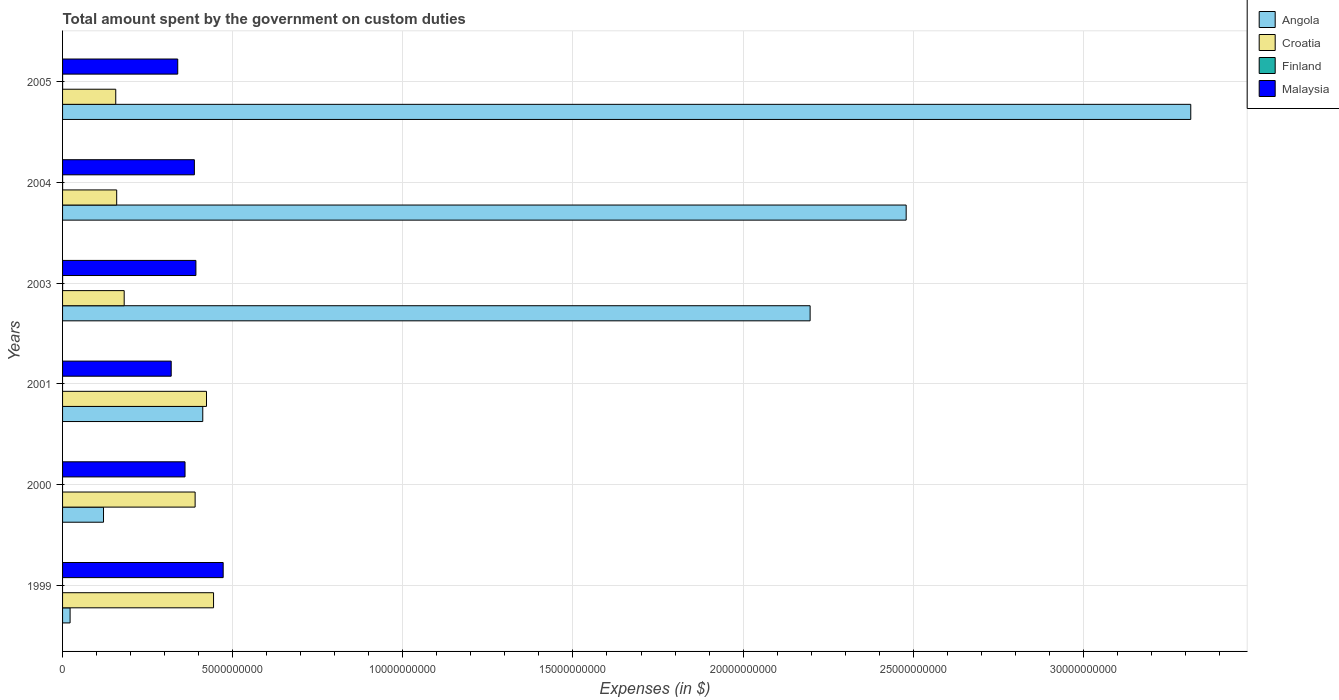Are the number of bars per tick equal to the number of legend labels?
Provide a succinct answer. No. How many bars are there on the 1st tick from the bottom?
Provide a succinct answer. 3. What is the label of the 2nd group of bars from the top?
Your answer should be compact. 2004. In how many cases, is the number of bars for a given year not equal to the number of legend labels?
Provide a succinct answer. 3. Across all years, what is the maximum amount spent on custom duties by the government in Croatia?
Your answer should be compact. 4.44e+09. Across all years, what is the minimum amount spent on custom duties by the government in Angola?
Your answer should be very brief. 2.21e+08. In which year was the amount spent on custom duties by the government in Malaysia maximum?
Provide a short and direct response. 1999. What is the total amount spent on custom duties by the government in Croatia in the graph?
Provide a short and direct response. 1.75e+1. What is the difference between the amount spent on custom duties by the government in Finland in 2003 and that in 2005?
Make the answer very short. 0. What is the difference between the amount spent on custom duties by the government in Malaysia in 2000 and the amount spent on custom duties by the government in Croatia in 2003?
Make the answer very short. 1.79e+09. What is the average amount spent on custom duties by the government in Finland per year?
Offer a very short reply. 5.00e+05. In the year 2003, what is the difference between the amount spent on custom duties by the government in Finland and amount spent on custom duties by the government in Croatia?
Make the answer very short. -1.81e+09. In how many years, is the amount spent on custom duties by the government in Croatia greater than 9000000000 $?
Ensure brevity in your answer.  0. What is the ratio of the amount spent on custom duties by the government in Croatia in 1999 to that in 2003?
Keep it short and to the point. 2.45. Is the amount spent on custom duties by the government in Angola in 2000 less than that in 2005?
Give a very brief answer. Yes. Is the difference between the amount spent on custom duties by the government in Finland in 2003 and 2005 greater than the difference between the amount spent on custom duties by the government in Croatia in 2003 and 2005?
Ensure brevity in your answer.  No. What is the difference between the highest and the second highest amount spent on custom duties by the government in Croatia?
Provide a succinct answer. 2.07e+08. What is the difference between the highest and the lowest amount spent on custom duties by the government in Angola?
Provide a succinct answer. 3.29e+1. How many bars are there?
Your response must be concise. 21. How many years are there in the graph?
Your answer should be very brief. 6. Does the graph contain any zero values?
Provide a short and direct response. Yes. Does the graph contain grids?
Give a very brief answer. Yes. Where does the legend appear in the graph?
Your response must be concise. Top right. What is the title of the graph?
Give a very brief answer. Total amount spent by the government on custom duties. What is the label or title of the X-axis?
Provide a short and direct response. Expenses (in $). What is the label or title of the Y-axis?
Ensure brevity in your answer.  Years. What is the Expenses (in $) of Angola in 1999?
Your answer should be compact. 2.21e+08. What is the Expenses (in $) in Croatia in 1999?
Your answer should be very brief. 4.44e+09. What is the Expenses (in $) of Finland in 1999?
Provide a succinct answer. 0. What is the Expenses (in $) in Malaysia in 1999?
Your answer should be compact. 4.72e+09. What is the Expenses (in $) in Angola in 2000?
Offer a terse response. 1.20e+09. What is the Expenses (in $) in Croatia in 2000?
Your response must be concise. 3.90e+09. What is the Expenses (in $) of Finland in 2000?
Offer a very short reply. 0. What is the Expenses (in $) of Malaysia in 2000?
Give a very brief answer. 3.60e+09. What is the Expenses (in $) of Angola in 2001?
Your answer should be compact. 4.12e+09. What is the Expenses (in $) of Croatia in 2001?
Your response must be concise. 4.23e+09. What is the Expenses (in $) of Malaysia in 2001?
Provide a succinct answer. 3.19e+09. What is the Expenses (in $) in Angola in 2003?
Your answer should be compact. 2.20e+1. What is the Expenses (in $) of Croatia in 2003?
Offer a very short reply. 1.81e+09. What is the Expenses (in $) in Malaysia in 2003?
Provide a succinct answer. 3.92e+09. What is the Expenses (in $) in Angola in 2004?
Your answer should be very brief. 2.48e+1. What is the Expenses (in $) of Croatia in 2004?
Your answer should be compact. 1.59e+09. What is the Expenses (in $) of Finland in 2004?
Offer a very short reply. 1.00e+06. What is the Expenses (in $) of Malaysia in 2004?
Make the answer very short. 3.87e+09. What is the Expenses (in $) of Angola in 2005?
Ensure brevity in your answer.  3.32e+1. What is the Expenses (in $) in Croatia in 2005?
Offer a very short reply. 1.56e+09. What is the Expenses (in $) in Malaysia in 2005?
Provide a short and direct response. 3.38e+09. Across all years, what is the maximum Expenses (in $) of Angola?
Your response must be concise. 3.32e+1. Across all years, what is the maximum Expenses (in $) in Croatia?
Ensure brevity in your answer.  4.44e+09. Across all years, what is the maximum Expenses (in $) of Finland?
Your answer should be compact. 1.00e+06. Across all years, what is the maximum Expenses (in $) in Malaysia?
Your answer should be very brief. 4.72e+09. Across all years, what is the minimum Expenses (in $) in Angola?
Your response must be concise. 2.21e+08. Across all years, what is the minimum Expenses (in $) in Croatia?
Provide a short and direct response. 1.56e+09. Across all years, what is the minimum Expenses (in $) of Finland?
Make the answer very short. 0. Across all years, what is the minimum Expenses (in $) of Malaysia?
Your answer should be compact. 3.19e+09. What is the total Expenses (in $) in Angola in the graph?
Offer a very short reply. 8.55e+1. What is the total Expenses (in $) in Croatia in the graph?
Offer a very short reply. 1.75e+1. What is the total Expenses (in $) of Finland in the graph?
Make the answer very short. 3.00e+06. What is the total Expenses (in $) of Malaysia in the graph?
Your response must be concise. 2.27e+1. What is the difference between the Expenses (in $) in Angola in 1999 and that in 2000?
Give a very brief answer. -9.82e+08. What is the difference between the Expenses (in $) in Croatia in 1999 and that in 2000?
Ensure brevity in your answer.  5.41e+08. What is the difference between the Expenses (in $) in Malaysia in 1999 and that in 2000?
Your answer should be compact. 1.12e+09. What is the difference between the Expenses (in $) in Angola in 1999 and that in 2001?
Offer a very short reply. -3.90e+09. What is the difference between the Expenses (in $) in Croatia in 1999 and that in 2001?
Offer a very short reply. 2.07e+08. What is the difference between the Expenses (in $) of Malaysia in 1999 and that in 2001?
Provide a succinct answer. 1.53e+09. What is the difference between the Expenses (in $) in Angola in 1999 and that in 2003?
Give a very brief answer. -2.17e+1. What is the difference between the Expenses (in $) in Croatia in 1999 and that in 2003?
Offer a terse response. 2.63e+09. What is the difference between the Expenses (in $) in Malaysia in 1999 and that in 2003?
Your answer should be very brief. 8.01e+08. What is the difference between the Expenses (in $) of Angola in 1999 and that in 2004?
Make the answer very short. -2.46e+1. What is the difference between the Expenses (in $) of Croatia in 1999 and that in 2004?
Your answer should be very brief. 2.85e+09. What is the difference between the Expenses (in $) of Malaysia in 1999 and that in 2004?
Your answer should be very brief. 8.46e+08. What is the difference between the Expenses (in $) of Angola in 1999 and that in 2005?
Your answer should be very brief. -3.29e+1. What is the difference between the Expenses (in $) of Croatia in 1999 and that in 2005?
Offer a very short reply. 2.87e+09. What is the difference between the Expenses (in $) in Malaysia in 1999 and that in 2005?
Your answer should be very brief. 1.34e+09. What is the difference between the Expenses (in $) of Angola in 2000 and that in 2001?
Make the answer very short. -2.92e+09. What is the difference between the Expenses (in $) of Croatia in 2000 and that in 2001?
Offer a very short reply. -3.34e+08. What is the difference between the Expenses (in $) in Malaysia in 2000 and that in 2001?
Make the answer very short. 4.06e+08. What is the difference between the Expenses (in $) in Angola in 2000 and that in 2003?
Offer a very short reply. -2.08e+1. What is the difference between the Expenses (in $) of Croatia in 2000 and that in 2003?
Your answer should be compact. 2.09e+09. What is the difference between the Expenses (in $) of Malaysia in 2000 and that in 2003?
Make the answer very short. -3.20e+08. What is the difference between the Expenses (in $) of Angola in 2000 and that in 2004?
Ensure brevity in your answer.  -2.36e+1. What is the difference between the Expenses (in $) of Croatia in 2000 and that in 2004?
Give a very brief answer. 2.31e+09. What is the difference between the Expenses (in $) of Malaysia in 2000 and that in 2004?
Your answer should be very brief. -2.75e+08. What is the difference between the Expenses (in $) in Angola in 2000 and that in 2005?
Make the answer very short. -3.20e+1. What is the difference between the Expenses (in $) in Croatia in 2000 and that in 2005?
Your answer should be compact. 2.33e+09. What is the difference between the Expenses (in $) of Malaysia in 2000 and that in 2005?
Ensure brevity in your answer.  2.14e+08. What is the difference between the Expenses (in $) in Angola in 2001 and that in 2003?
Make the answer very short. -1.79e+1. What is the difference between the Expenses (in $) in Croatia in 2001 and that in 2003?
Provide a succinct answer. 2.42e+09. What is the difference between the Expenses (in $) of Malaysia in 2001 and that in 2003?
Give a very brief answer. -7.26e+08. What is the difference between the Expenses (in $) in Angola in 2001 and that in 2004?
Offer a terse response. -2.07e+1. What is the difference between the Expenses (in $) of Croatia in 2001 and that in 2004?
Give a very brief answer. 2.64e+09. What is the difference between the Expenses (in $) in Malaysia in 2001 and that in 2004?
Offer a terse response. -6.81e+08. What is the difference between the Expenses (in $) in Angola in 2001 and that in 2005?
Ensure brevity in your answer.  -2.90e+1. What is the difference between the Expenses (in $) of Croatia in 2001 and that in 2005?
Keep it short and to the point. 2.67e+09. What is the difference between the Expenses (in $) of Malaysia in 2001 and that in 2005?
Your response must be concise. -1.92e+08. What is the difference between the Expenses (in $) in Angola in 2003 and that in 2004?
Make the answer very short. -2.82e+09. What is the difference between the Expenses (in $) of Croatia in 2003 and that in 2004?
Ensure brevity in your answer.  2.20e+08. What is the difference between the Expenses (in $) of Malaysia in 2003 and that in 2004?
Offer a terse response. 4.50e+07. What is the difference between the Expenses (in $) in Angola in 2003 and that in 2005?
Your answer should be compact. -1.12e+1. What is the difference between the Expenses (in $) of Croatia in 2003 and that in 2005?
Ensure brevity in your answer.  2.48e+08. What is the difference between the Expenses (in $) of Finland in 2003 and that in 2005?
Offer a very short reply. 0. What is the difference between the Expenses (in $) of Malaysia in 2003 and that in 2005?
Offer a very short reply. 5.34e+08. What is the difference between the Expenses (in $) of Angola in 2004 and that in 2005?
Provide a succinct answer. -8.36e+09. What is the difference between the Expenses (in $) of Croatia in 2004 and that in 2005?
Make the answer very short. 2.78e+07. What is the difference between the Expenses (in $) of Finland in 2004 and that in 2005?
Provide a succinct answer. 0. What is the difference between the Expenses (in $) in Malaysia in 2004 and that in 2005?
Provide a succinct answer. 4.89e+08. What is the difference between the Expenses (in $) in Angola in 1999 and the Expenses (in $) in Croatia in 2000?
Keep it short and to the point. -3.67e+09. What is the difference between the Expenses (in $) in Angola in 1999 and the Expenses (in $) in Malaysia in 2000?
Your answer should be very brief. -3.38e+09. What is the difference between the Expenses (in $) in Croatia in 1999 and the Expenses (in $) in Malaysia in 2000?
Provide a short and direct response. 8.38e+08. What is the difference between the Expenses (in $) in Angola in 1999 and the Expenses (in $) in Croatia in 2001?
Offer a very short reply. -4.01e+09. What is the difference between the Expenses (in $) in Angola in 1999 and the Expenses (in $) in Malaysia in 2001?
Give a very brief answer. -2.97e+09. What is the difference between the Expenses (in $) in Croatia in 1999 and the Expenses (in $) in Malaysia in 2001?
Offer a very short reply. 1.24e+09. What is the difference between the Expenses (in $) in Angola in 1999 and the Expenses (in $) in Croatia in 2003?
Offer a very short reply. -1.59e+09. What is the difference between the Expenses (in $) in Angola in 1999 and the Expenses (in $) in Finland in 2003?
Give a very brief answer. 2.20e+08. What is the difference between the Expenses (in $) of Angola in 1999 and the Expenses (in $) of Malaysia in 2003?
Provide a short and direct response. -3.70e+09. What is the difference between the Expenses (in $) in Croatia in 1999 and the Expenses (in $) in Finland in 2003?
Keep it short and to the point. 4.44e+09. What is the difference between the Expenses (in $) of Croatia in 1999 and the Expenses (in $) of Malaysia in 2003?
Offer a very short reply. 5.18e+08. What is the difference between the Expenses (in $) of Angola in 1999 and the Expenses (in $) of Croatia in 2004?
Keep it short and to the point. -1.37e+09. What is the difference between the Expenses (in $) of Angola in 1999 and the Expenses (in $) of Finland in 2004?
Ensure brevity in your answer.  2.20e+08. What is the difference between the Expenses (in $) of Angola in 1999 and the Expenses (in $) of Malaysia in 2004?
Your response must be concise. -3.65e+09. What is the difference between the Expenses (in $) of Croatia in 1999 and the Expenses (in $) of Finland in 2004?
Offer a very short reply. 4.44e+09. What is the difference between the Expenses (in $) of Croatia in 1999 and the Expenses (in $) of Malaysia in 2004?
Keep it short and to the point. 5.63e+08. What is the difference between the Expenses (in $) of Angola in 1999 and the Expenses (in $) of Croatia in 2005?
Provide a short and direct response. -1.34e+09. What is the difference between the Expenses (in $) in Angola in 1999 and the Expenses (in $) in Finland in 2005?
Your response must be concise. 2.20e+08. What is the difference between the Expenses (in $) of Angola in 1999 and the Expenses (in $) of Malaysia in 2005?
Ensure brevity in your answer.  -3.16e+09. What is the difference between the Expenses (in $) of Croatia in 1999 and the Expenses (in $) of Finland in 2005?
Your answer should be compact. 4.44e+09. What is the difference between the Expenses (in $) of Croatia in 1999 and the Expenses (in $) of Malaysia in 2005?
Offer a very short reply. 1.05e+09. What is the difference between the Expenses (in $) in Angola in 2000 and the Expenses (in $) in Croatia in 2001?
Provide a short and direct response. -3.03e+09. What is the difference between the Expenses (in $) of Angola in 2000 and the Expenses (in $) of Malaysia in 2001?
Provide a short and direct response. -1.99e+09. What is the difference between the Expenses (in $) of Croatia in 2000 and the Expenses (in $) of Malaysia in 2001?
Your response must be concise. 7.03e+08. What is the difference between the Expenses (in $) of Angola in 2000 and the Expenses (in $) of Croatia in 2003?
Your answer should be very brief. -6.08e+08. What is the difference between the Expenses (in $) of Angola in 2000 and the Expenses (in $) of Finland in 2003?
Provide a succinct answer. 1.20e+09. What is the difference between the Expenses (in $) of Angola in 2000 and the Expenses (in $) of Malaysia in 2003?
Make the answer very short. -2.72e+09. What is the difference between the Expenses (in $) of Croatia in 2000 and the Expenses (in $) of Finland in 2003?
Your answer should be compact. 3.90e+09. What is the difference between the Expenses (in $) in Croatia in 2000 and the Expenses (in $) in Malaysia in 2003?
Provide a succinct answer. -2.30e+07. What is the difference between the Expenses (in $) of Angola in 2000 and the Expenses (in $) of Croatia in 2004?
Your answer should be very brief. -3.87e+08. What is the difference between the Expenses (in $) of Angola in 2000 and the Expenses (in $) of Finland in 2004?
Ensure brevity in your answer.  1.20e+09. What is the difference between the Expenses (in $) of Angola in 2000 and the Expenses (in $) of Malaysia in 2004?
Give a very brief answer. -2.67e+09. What is the difference between the Expenses (in $) in Croatia in 2000 and the Expenses (in $) in Finland in 2004?
Keep it short and to the point. 3.90e+09. What is the difference between the Expenses (in $) in Croatia in 2000 and the Expenses (in $) in Malaysia in 2004?
Your response must be concise. 2.20e+07. What is the difference between the Expenses (in $) in Angola in 2000 and the Expenses (in $) in Croatia in 2005?
Ensure brevity in your answer.  -3.60e+08. What is the difference between the Expenses (in $) in Angola in 2000 and the Expenses (in $) in Finland in 2005?
Provide a short and direct response. 1.20e+09. What is the difference between the Expenses (in $) of Angola in 2000 and the Expenses (in $) of Malaysia in 2005?
Provide a succinct answer. -2.18e+09. What is the difference between the Expenses (in $) of Croatia in 2000 and the Expenses (in $) of Finland in 2005?
Give a very brief answer. 3.90e+09. What is the difference between the Expenses (in $) of Croatia in 2000 and the Expenses (in $) of Malaysia in 2005?
Keep it short and to the point. 5.11e+08. What is the difference between the Expenses (in $) of Angola in 2001 and the Expenses (in $) of Croatia in 2003?
Provide a short and direct response. 2.31e+09. What is the difference between the Expenses (in $) of Angola in 2001 and the Expenses (in $) of Finland in 2003?
Give a very brief answer. 4.12e+09. What is the difference between the Expenses (in $) in Angola in 2001 and the Expenses (in $) in Malaysia in 2003?
Provide a short and direct response. 2.01e+08. What is the difference between the Expenses (in $) in Croatia in 2001 and the Expenses (in $) in Finland in 2003?
Ensure brevity in your answer.  4.23e+09. What is the difference between the Expenses (in $) in Croatia in 2001 and the Expenses (in $) in Malaysia in 2003?
Your response must be concise. 3.11e+08. What is the difference between the Expenses (in $) in Angola in 2001 and the Expenses (in $) in Croatia in 2004?
Offer a very short reply. 2.53e+09. What is the difference between the Expenses (in $) in Angola in 2001 and the Expenses (in $) in Finland in 2004?
Your response must be concise. 4.12e+09. What is the difference between the Expenses (in $) in Angola in 2001 and the Expenses (in $) in Malaysia in 2004?
Your response must be concise. 2.46e+08. What is the difference between the Expenses (in $) of Croatia in 2001 and the Expenses (in $) of Finland in 2004?
Your response must be concise. 4.23e+09. What is the difference between the Expenses (in $) of Croatia in 2001 and the Expenses (in $) of Malaysia in 2004?
Make the answer very short. 3.56e+08. What is the difference between the Expenses (in $) in Angola in 2001 and the Expenses (in $) in Croatia in 2005?
Your answer should be compact. 2.56e+09. What is the difference between the Expenses (in $) in Angola in 2001 and the Expenses (in $) in Finland in 2005?
Ensure brevity in your answer.  4.12e+09. What is the difference between the Expenses (in $) of Angola in 2001 and the Expenses (in $) of Malaysia in 2005?
Your answer should be very brief. 7.35e+08. What is the difference between the Expenses (in $) of Croatia in 2001 and the Expenses (in $) of Finland in 2005?
Offer a terse response. 4.23e+09. What is the difference between the Expenses (in $) in Croatia in 2001 and the Expenses (in $) in Malaysia in 2005?
Provide a short and direct response. 8.45e+08. What is the difference between the Expenses (in $) of Angola in 2003 and the Expenses (in $) of Croatia in 2004?
Ensure brevity in your answer.  2.04e+1. What is the difference between the Expenses (in $) of Angola in 2003 and the Expenses (in $) of Finland in 2004?
Your answer should be very brief. 2.20e+1. What is the difference between the Expenses (in $) in Angola in 2003 and the Expenses (in $) in Malaysia in 2004?
Make the answer very short. 1.81e+1. What is the difference between the Expenses (in $) of Croatia in 2003 and the Expenses (in $) of Finland in 2004?
Give a very brief answer. 1.81e+09. What is the difference between the Expenses (in $) of Croatia in 2003 and the Expenses (in $) of Malaysia in 2004?
Keep it short and to the point. -2.06e+09. What is the difference between the Expenses (in $) of Finland in 2003 and the Expenses (in $) of Malaysia in 2004?
Ensure brevity in your answer.  -3.87e+09. What is the difference between the Expenses (in $) in Angola in 2003 and the Expenses (in $) in Croatia in 2005?
Keep it short and to the point. 2.04e+1. What is the difference between the Expenses (in $) of Angola in 2003 and the Expenses (in $) of Finland in 2005?
Provide a succinct answer. 2.20e+1. What is the difference between the Expenses (in $) of Angola in 2003 and the Expenses (in $) of Malaysia in 2005?
Ensure brevity in your answer.  1.86e+1. What is the difference between the Expenses (in $) of Croatia in 2003 and the Expenses (in $) of Finland in 2005?
Keep it short and to the point. 1.81e+09. What is the difference between the Expenses (in $) in Croatia in 2003 and the Expenses (in $) in Malaysia in 2005?
Give a very brief answer. -1.57e+09. What is the difference between the Expenses (in $) of Finland in 2003 and the Expenses (in $) of Malaysia in 2005?
Keep it short and to the point. -3.38e+09. What is the difference between the Expenses (in $) of Angola in 2004 and the Expenses (in $) of Croatia in 2005?
Offer a terse response. 2.32e+1. What is the difference between the Expenses (in $) of Angola in 2004 and the Expenses (in $) of Finland in 2005?
Give a very brief answer. 2.48e+1. What is the difference between the Expenses (in $) in Angola in 2004 and the Expenses (in $) in Malaysia in 2005?
Provide a short and direct response. 2.14e+1. What is the difference between the Expenses (in $) of Croatia in 2004 and the Expenses (in $) of Finland in 2005?
Offer a terse response. 1.59e+09. What is the difference between the Expenses (in $) of Croatia in 2004 and the Expenses (in $) of Malaysia in 2005?
Ensure brevity in your answer.  -1.79e+09. What is the difference between the Expenses (in $) of Finland in 2004 and the Expenses (in $) of Malaysia in 2005?
Give a very brief answer. -3.38e+09. What is the average Expenses (in $) in Angola per year?
Give a very brief answer. 1.42e+1. What is the average Expenses (in $) of Croatia per year?
Provide a short and direct response. 2.92e+09. What is the average Expenses (in $) of Finland per year?
Your answer should be compact. 5.00e+05. What is the average Expenses (in $) in Malaysia per year?
Provide a short and direct response. 3.78e+09. In the year 1999, what is the difference between the Expenses (in $) in Angola and Expenses (in $) in Croatia?
Provide a succinct answer. -4.22e+09. In the year 1999, what is the difference between the Expenses (in $) of Angola and Expenses (in $) of Malaysia?
Offer a very short reply. -4.50e+09. In the year 1999, what is the difference between the Expenses (in $) of Croatia and Expenses (in $) of Malaysia?
Offer a very short reply. -2.83e+08. In the year 2000, what is the difference between the Expenses (in $) in Angola and Expenses (in $) in Croatia?
Your answer should be very brief. -2.69e+09. In the year 2000, what is the difference between the Expenses (in $) in Angola and Expenses (in $) in Malaysia?
Provide a succinct answer. -2.40e+09. In the year 2000, what is the difference between the Expenses (in $) of Croatia and Expenses (in $) of Malaysia?
Provide a succinct answer. 2.97e+08. In the year 2001, what is the difference between the Expenses (in $) of Angola and Expenses (in $) of Croatia?
Offer a very short reply. -1.10e+08. In the year 2001, what is the difference between the Expenses (in $) in Angola and Expenses (in $) in Malaysia?
Your answer should be very brief. 9.27e+08. In the year 2001, what is the difference between the Expenses (in $) of Croatia and Expenses (in $) of Malaysia?
Provide a succinct answer. 1.04e+09. In the year 2003, what is the difference between the Expenses (in $) of Angola and Expenses (in $) of Croatia?
Offer a very short reply. 2.02e+1. In the year 2003, what is the difference between the Expenses (in $) in Angola and Expenses (in $) in Finland?
Offer a very short reply. 2.20e+1. In the year 2003, what is the difference between the Expenses (in $) of Angola and Expenses (in $) of Malaysia?
Your answer should be very brief. 1.81e+1. In the year 2003, what is the difference between the Expenses (in $) in Croatia and Expenses (in $) in Finland?
Your answer should be very brief. 1.81e+09. In the year 2003, what is the difference between the Expenses (in $) in Croatia and Expenses (in $) in Malaysia?
Provide a short and direct response. -2.11e+09. In the year 2003, what is the difference between the Expenses (in $) in Finland and Expenses (in $) in Malaysia?
Give a very brief answer. -3.92e+09. In the year 2004, what is the difference between the Expenses (in $) of Angola and Expenses (in $) of Croatia?
Provide a short and direct response. 2.32e+1. In the year 2004, what is the difference between the Expenses (in $) in Angola and Expenses (in $) in Finland?
Offer a terse response. 2.48e+1. In the year 2004, what is the difference between the Expenses (in $) of Angola and Expenses (in $) of Malaysia?
Keep it short and to the point. 2.09e+1. In the year 2004, what is the difference between the Expenses (in $) in Croatia and Expenses (in $) in Finland?
Ensure brevity in your answer.  1.59e+09. In the year 2004, what is the difference between the Expenses (in $) of Croatia and Expenses (in $) of Malaysia?
Your response must be concise. -2.28e+09. In the year 2004, what is the difference between the Expenses (in $) in Finland and Expenses (in $) in Malaysia?
Offer a terse response. -3.87e+09. In the year 2005, what is the difference between the Expenses (in $) of Angola and Expenses (in $) of Croatia?
Your answer should be very brief. 3.16e+1. In the year 2005, what is the difference between the Expenses (in $) in Angola and Expenses (in $) in Finland?
Your answer should be compact. 3.32e+1. In the year 2005, what is the difference between the Expenses (in $) of Angola and Expenses (in $) of Malaysia?
Provide a short and direct response. 2.98e+1. In the year 2005, what is the difference between the Expenses (in $) of Croatia and Expenses (in $) of Finland?
Offer a terse response. 1.56e+09. In the year 2005, what is the difference between the Expenses (in $) in Croatia and Expenses (in $) in Malaysia?
Make the answer very short. -1.82e+09. In the year 2005, what is the difference between the Expenses (in $) of Finland and Expenses (in $) of Malaysia?
Ensure brevity in your answer.  -3.38e+09. What is the ratio of the Expenses (in $) in Angola in 1999 to that in 2000?
Your response must be concise. 0.18. What is the ratio of the Expenses (in $) of Croatia in 1999 to that in 2000?
Ensure brevity in your answer.  1.14. What is the ratio of the Expenses (in $) in Malaysia in 1999 to that in 2000?
Your answer should be compact. 1.31. What is the ratio of the Expenses (in $) in Angola in 1999 to that in 2001?
Provide a short and direct response. 0.05. What is the ratio of the Expenses (in $) of Croatia in 1999 to that in 2001?
Your answer should be compact. 1.05. What is the ratio of the Expenses (in $) of Malaysia in 1999 to that in 2001?
Offer a very short reply. 1.48. What is the ratio of the Expenses (in $) of Angola in 1999 to that in 2003?
Your answer should be very brief. 0.01. What is the ratio of the Expenses (in $) of Croatia in 1999 to that in 2003?
Offer a very short reply. 2.45. What is the ratio of the Expenses (in $) in Malaysia in 1999 to that in 2003?
Offer a terse response. 1.2. What is the ratio of the Expenses (in $) in Angola in 1999 to that in 2004?
Provide a short and direct response. 0.01. What is the ratio of the Expenses (in $) of Croatia in 1999 to that in 2004?
Your answer should be very brief. 2.79. What is the ratio of the Expenses (in $) of Malaysia in 1999 to that in 2004?
Provide a short and direct response. 1.22. What is the ratio of the Expenses (in $) in Angola in 1999 to that in 2005?
Your response must be concise. 0.01. What is the ratio of the Expenses (in $) in Croatia in 1999 to that in 2005?
Make the answer very short. 2.84. What is the ratio of the Expenses (in $) of Malaysia in 1999 to that in 2005?
Make the answer very short. 1.39. What is the ratio of the Expenses (in $) of Angola in 2000 to that in 2001?
Make the answer very short. 0.29. What is the ratio of the Expenses (in $) in Croatia in 2000 to that in 2001?
Give a very brief answer. 0.92. What is the ratio of the Expenses (in $) in Malaysia in 2000 to that in 2001?
Offer a terse response. 1.13. What is the ratio of the Expenses (in $) in Angola in 2000 to that in 2003?
Your response must be concise. 0.05. What is the ratio of the Expenses (in $) in Croatia in 2000 to that in 2003?
Offer a very short reply. 2.15. What is the ratio of the Expenses (in $) of Malaysia in 2000 to that in 2003?
Make the answer very short. 0.92. What is the ratio of the Expenses (in $) of Angola in 2000 to that in 2004?
Offer a very short reply. 0.05. What is the ratio of the Expenses (in $) in Croatia in 2000 to that in 2004?
Keep it short and to the point. 2.45. What is the ratio of the Expenses (in $) in Malaysia in 2000 to that in 2004?
Your answer should be very brief. 0.93. What is the ratio of the Expenses (in $) in Angola in 2000 to that in 2005?
Ensure brevity in your answer.  0.04. What is the ratio of the Expenses (in $) of Croatia in 2000 to that in 2005?
Provide a short and direct response. 2.49. What is the ratio of the Expenses (in $) in Malaysia in 2000 to that in 2005?
Make the answer very short. 1.06. What is the ratio of the Expenses (in $) in Angola in 2001 to that in 2003?
Offer a terse response. 0.19. What is the ratio of the Expenses (in $) of Croatia in 2001 to that in 2003?
Make the answer very short. 2.34. What is the ratio of the Expenses (in $) in Malaysia in 2001 to that in 2003?
Your answer should be compact. 0.81. What is the ratio of the Expenses (in $) in Angola in 2001 to that in 2004?
Offer a terse response. 0.17. What is the ratio of the Expenses (in $) in Croatia in 2001 to that in 2004?
Offer a terse response. 2.66. What is the ratio of the Expenses (in $) of Malaysia in 2001 to that in 2004?
Your answer should be compact. 0.82. What is the ratio of the Expenses (in $) in Angola in 2001 to that in 2005?
Keep it short and to the point. 0.12. What is the ratio of the Expenses (in $) in Croatia in 2001 to that in 2005?
Your response must be concise. 2.71. What is the ratio of the Expenses (in $) of Malaysia in 2001 to that in 2005?
Make the answer very short. 0.94. What is the ratio of the Expenses (in $) of Angola in 2003 to that in 2004?
Offer a very short reply. 0.89. What is the ratio of the Expenses (in $) in Croatia in 2003 to that in 2004?
Make the answer very short. 1.14. What is the ratio of the Expenses (in $) of Finland in 2003 to that in 2004?
Offer a very short reply. 1. What is the ratio of the Expenses (in $) in Malaysia in 2003 to that in 2004?
Keep it short and to the point. 1.01. What is the ratio of the Expenses (in $) of Angola in 2003 to that in 2005?
Keep it short and to the point. 0.66. What is the ratio of the Expenses (in $) of Croatia in 2003 to that in 2005?
Offer a very short reply. 1.16. What is the ratio of the Expenses (in $) in Malaysia in 2003 to that in 2005?
Ensure brevity in your answer.  1.16. What is the ratio of the Expenses (in $) in Angola in 2004 to that in 2005?
Make the answer very short. 0.75. What is the ratio of the Expenses (in $) of Croatia in 2004 to that in 2005?
Provide a short and direct response. 1.02. What is the ratio of the Expenses (in $) of Malaysia in 2004 to that in 2005?
Offer a terse response. 1.14. What is the difference between the highest and the second highest Expenses (in $) in Angola?
Your response must be concise. 8.36e+09. What is the difference between the highest and the second highest Expenses (in $) of Croatia?
Offer a terse response. 2.07e+08. What is the difference between the highest and the second highest Expenses (in $) of Finland?
Make the answer very short. 0. What is the difference between the highest and the second highest Expenses (in $) of Malaysia?
Keep it short and to the point. 8.01e+08. What is the difference between the highest and the lowest Expenses (in $) in Angola?
Provide a succinct answer. 3.29e+1. What is the difference between the highest and the lowest Expenses (in $) of Croatia?
Make the answer very short. 2.87e+09. What is the difference between the highest and the lowest Expenses (in $) of Finland?
Your answer should be very brief. 1.00e+06. What is the difference between the highest and the lowest Expenses (in $) of Malaysia?
Give a very brief answer. 1.53e+09. 